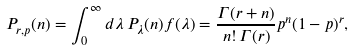Convert formula to latex. <formula><loc_0><loc_0><loc_500><loc_500>P _ { r , p } ( n ) = \int _ { 0 } ^ { \infty } d \lambda \, P _ { \lambda } ( n ) f ( \lambda ) = \frac { \Gamma ( r + n ) } { n ! \, \Gamma ( r ) } p ^ { n } ( 1 - p ) ^ { r } ,</formula> 